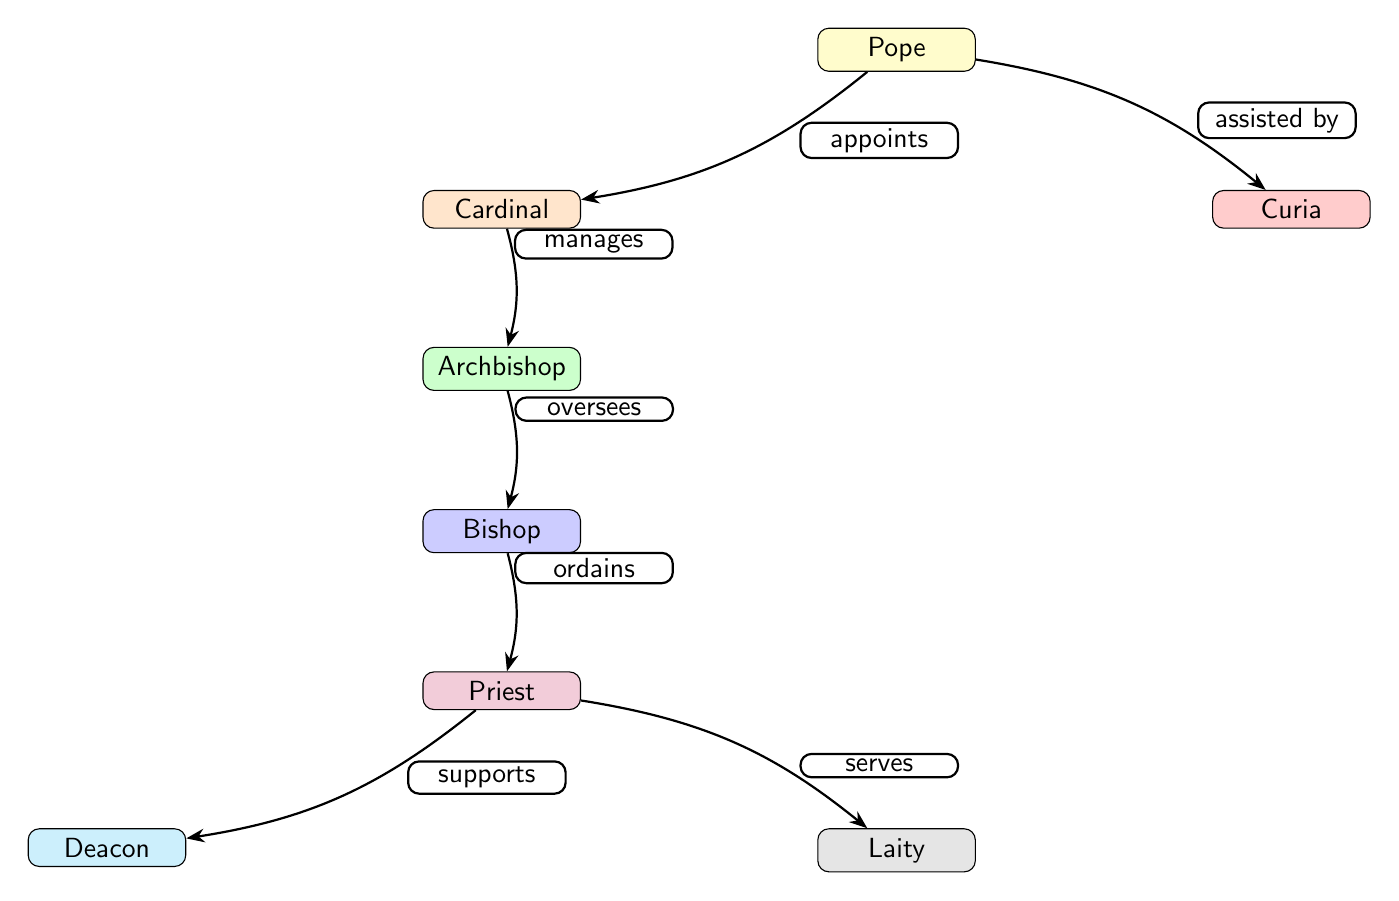What is the highest position in the Catholic Church? The diagram indicates that the "Pope" is at the top of the hierarchical structure, representing the highest position in the Catholic Church.
Answer: Pope How many levels are present in the hierarchy from the Pope to the Laity? The hierarchy contains six levels: Pope, Cardinal, Archbishop, Bishop, Priest, Deacon, and Laity, totaling seven nodes.
Answer: Seven What relationship does the Pope have with the Curia? The diagram shows that the Pope is "assisted by" the Curia, indicating a supportive role within the hierarchy.
Answer: Assisted by Who does a Bishop ordain? According to the diagram, the Bishop "ordains" the Priest, signifying a direct hierarchical relationship.
Answer: Priest What does a Priest do for the Laity? The diagram states that the Priest "serves" the Laity, indicating the sharing of spiritual services.
Answer: Serves What role does a Cardinal play in relation to an Archbishop? The diagram describes the Cardinal as "manages" the Archbishop, which highlights the Cardinal's oversight and authority over Archbishops.
Answer: Manages Which two positions are directly under a Priest in the hierarchy? The diagram shows that the positions directly under a Priest are Deacon and Laity, indicating a branch from the Priest position.
Answer: Deacon and Laity In the order of hierarchy, who is directly below the Cardinal? According to the flow of the diagram, the Archbishop is directly below the Cardinal, marking a clear hierarchical relationship.
Answer: Archbishop If the Pope appoints a Cardinal, what is the Cardinal's function? The diagram indicates that the Cardinal's function is to "manage" the Archbishop, illustrating the Cardinal's role in the hierarchical structure.
Answer: Manages 